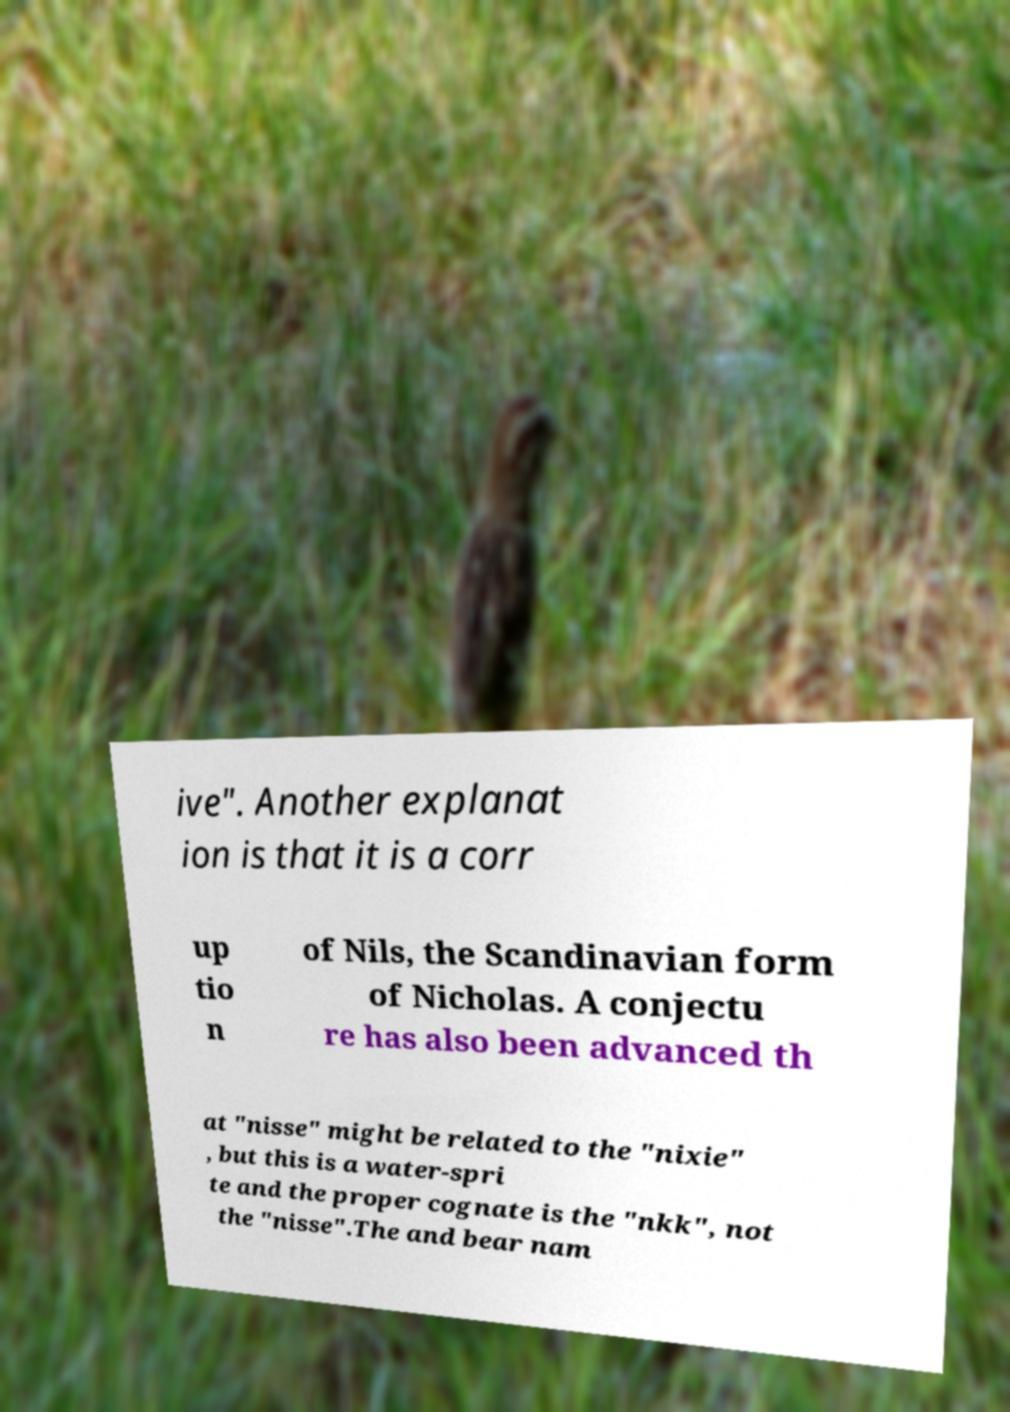Can you read and provide the text displayed in the image?This photo seems to have some interesting text. Can you extract and type it out for me? ive". Another explanat ion is that it is a corr up tio n of Nils, the Scandinavian form of Nicholas. A conjectu re has also been advanced th at "nisse" might be related to the "nixie" , but this is a water-spri te and the proper cognate is the "nkk", not the "nisse".The and bear nam 